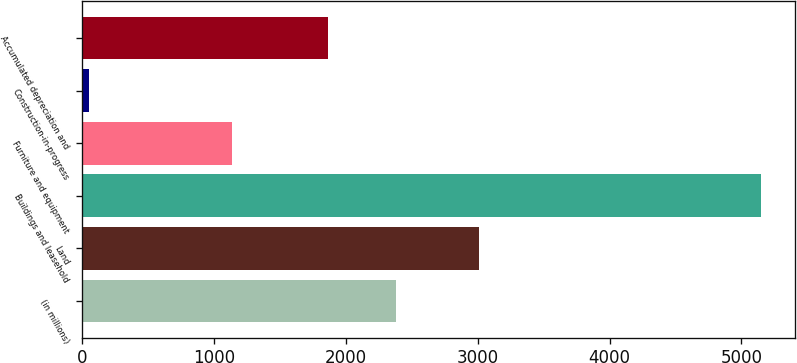Convert chart. <chart><loc_0><loc_0><loc_500><loc_500><bar_chart><fcel>(in millions)<fcel>Land<fcel>Buildings and leasehold<fcel>Furniture and equipment<fcel>Construction-in-progress<fcel>Accumulated depreciation and<nl><fcel>2378.7<fcel>3009<fcel>5150<fcel>1140<fcel>53<fcel>1869<nl></chart> 